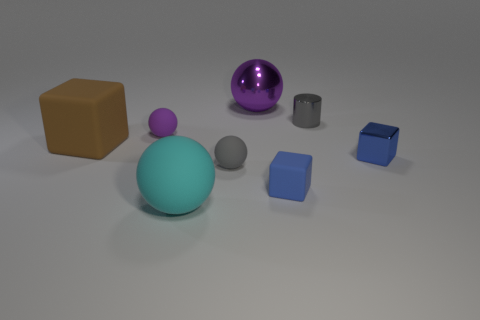How many brown objects are there?
Provide a succinct answer. 1. Is the number of blue cubes that are behind the tiny blue shiny thing the same as the number of big purple shiny objects to the right of the big brown thing?
Your answer should be compact. No. Are there any big rubber things to the right of the purple metal ball?
Provide a short and direct response. No. What is the color of the rubber cube to the left of the purple metallic ball?
Give a very brief answer. Brown. There is a tiny block that is in front of the gray object on the left side of the purple metal object; what is it made of?
Your answer should be very brief. Rubber. Are there fewer big balls that are behind the metallic cylinder than big rubber balls to the right of the big purple ball?
Give a very brief answer. No. What number of red objects are either metal spheres or rubber spheres?
Your response must be concise. 0. Are there an equal number of big cyan matte things that are left of the cyan ball and small blue objects?
Your response must be concise. No. How many objects are either yellow rubber cubes or cubes left of the shiny sphere?
Give a very brief answer. 1. Does the big metallic ball have the same color as the big rubber sphere?
Your answer should be very brief. No. 